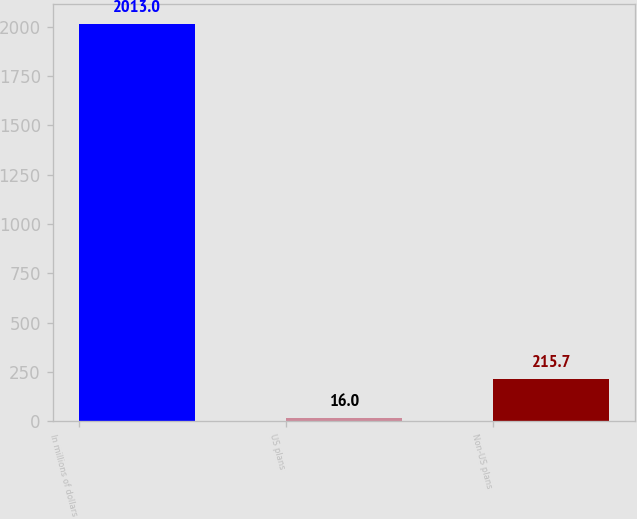<chart> <loc_0><loc_0><loc_500><loc_500><bar_chart><fcel>In millions of dollars<fcel>US plans<fcel>Non-US plans<nl><fcel>2013<fcel>16<fcel>215.7<nl></chart> 